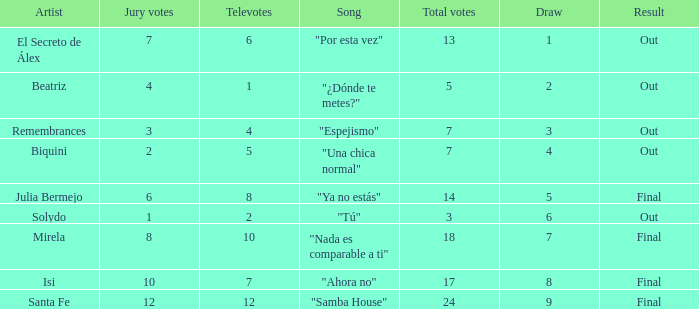Name the number of song for julia bermejo 1.0. 